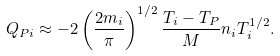<formula> <loc_0><loc_0><loc_500><loc_500>Q _ { P i } \approx - 2 \left ( \frac { 2 m _ { i } } { \pi } \right ) ^ { 1 / 2 } \frac { T _ { i } - T _ { P } } { M } n _ { i } T _ { i } ^ { 1 / 2 } .</formula> 